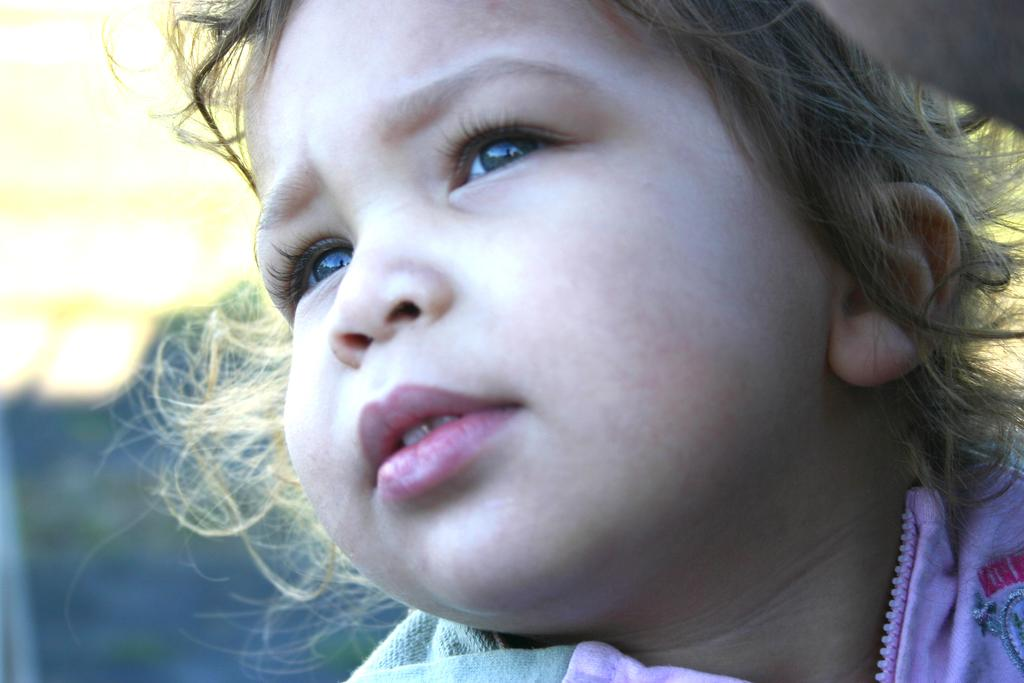What is the main subject of the image? The main subject of the image is a child's face. What type of fork can be seen in the child's hand in the image? There is no fork present in the image; it only features a child's face. How many fingers can be seen on the child's hand in the image? The image only shows the child's face, and no fingers are visible. 